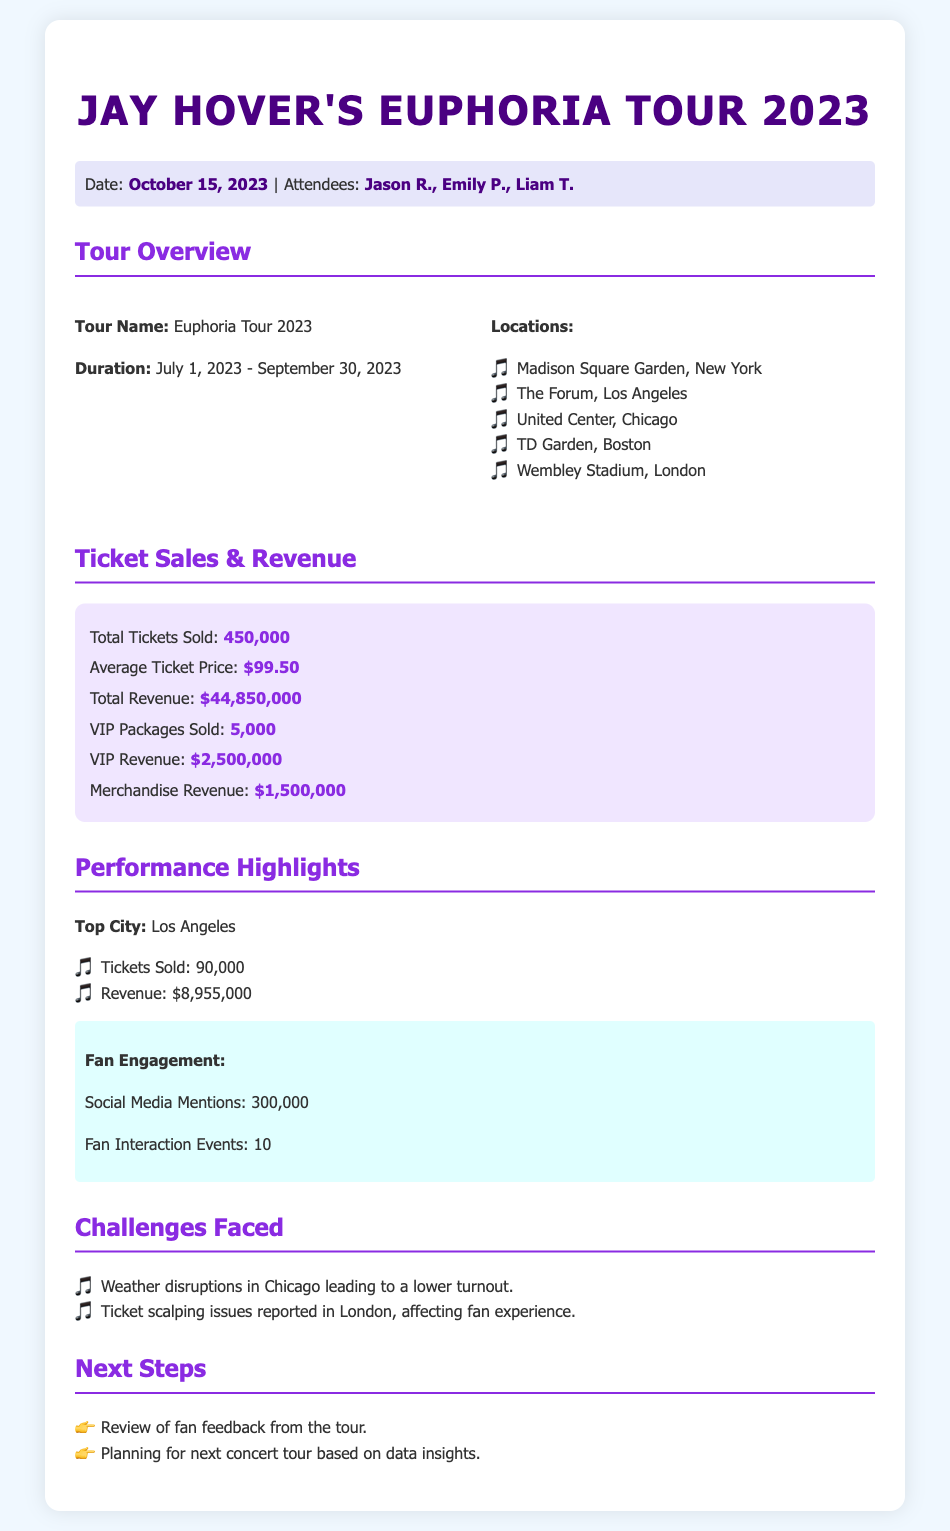What was the total number of tickets sold? The total number of tickets sold is clearly stated in the document under the Ticket Sales & Revenue section.
Answer: 450,000 What was the average ticket price? The average ticket price can be found in the Ticket Sales & Revenue section of the document.
Answer: $99.50 What was the total revenue generated from the tour? The document specifies the total revenue generated from ticket sales, VIP packages, and merchandise.
Answer: $44,850,000 How many VIP packages were sold? The count of VIP packages sold is explicitly mentioned in the Ticket Sales & Revenue section.
Answer: 5,000 Which city recorded the highest ticket sales? This information is provided under the Performance Highlights section of the document.
Answer: Los Angeles What was the revenue generated from the Los Angeles concert? The revenue from Los Angeles is detailed under the Performance Highlights section.
Answer: $8,955,000 How many social media mentions were there regarding the tour? The number of social media mentions can be found in the Fan Engagement section.
Answer: 300,000 What were the dates of the Euphoria Tour 2023? The tour duration is mentioned clearly in the Tour Overview section.
Answer: July 1, 2023 - September 30, 2023 What were some challenges faced during the tour? The challenges are listed in their own section within the document, detailing specific issues.
Answer: Weather disruptions in Chicago; Ticket scalping issues in London 